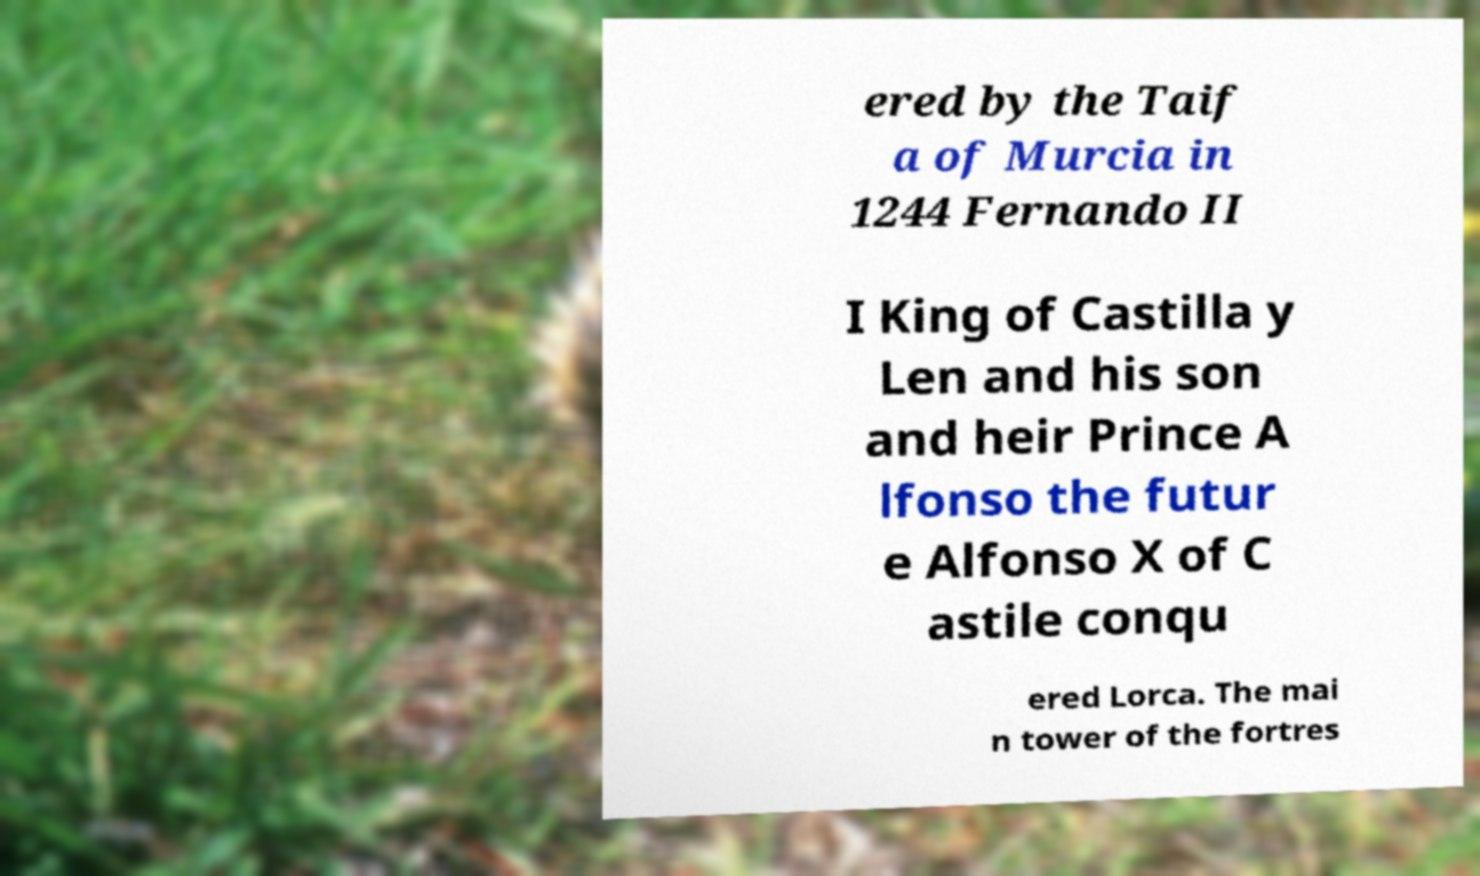Please read and relay the text visible in this image. What does it say? ered by the Taif a of Murcia in 1244 Fernando II I King of Castilla y Len and his son and heir Prince A lfonso the futur e Alfonso X of C astile conqu ered Lorca. The mai n tower of the fortres 